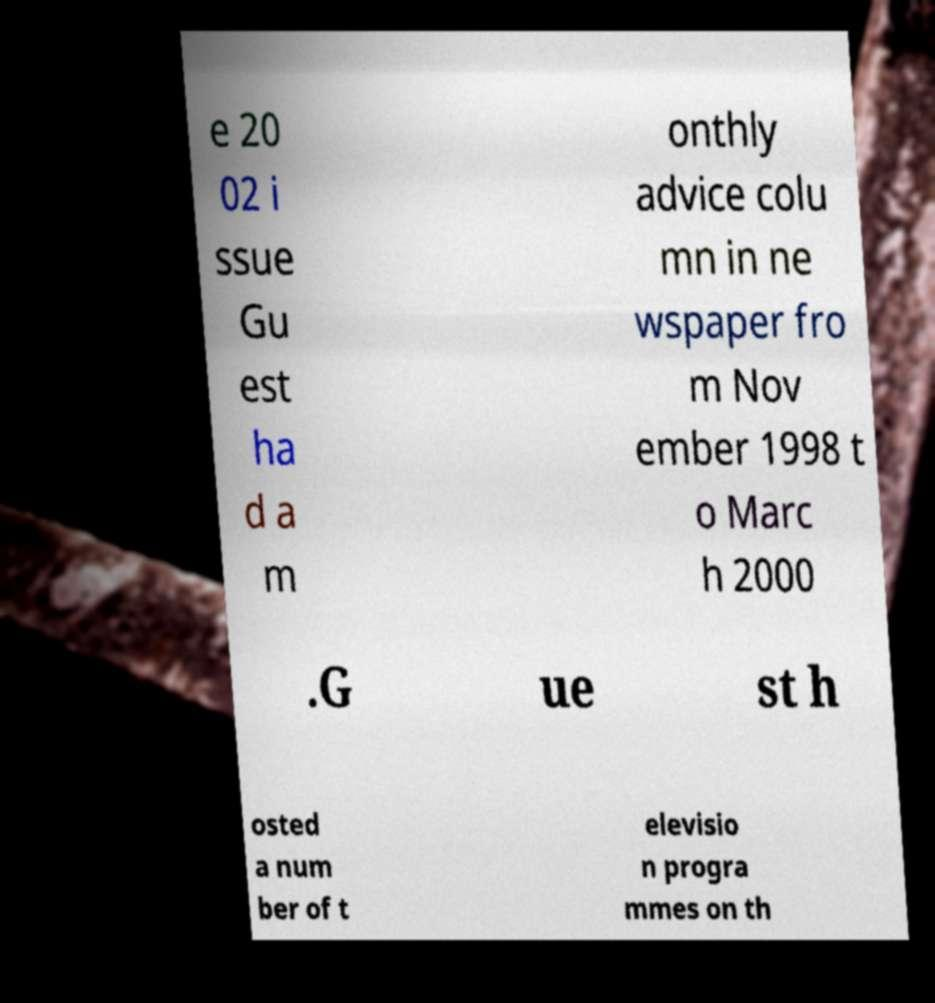Please identify and transcribe the text found in this image. e 20 02 i ssue Gu est ha d a m onthly advice colu mn in ne wspaper fro m Nov ember 1998 t o Marc h 2000 .G ue st h osted a num ber of t elevisio n progra mmes on th 